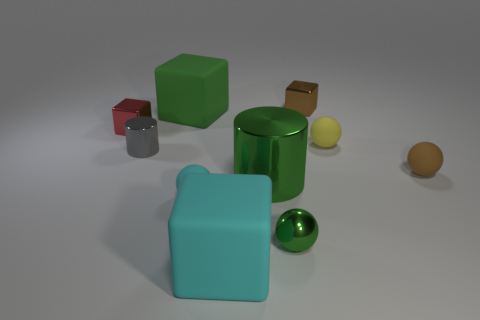Is there a tiny gray sphere that has the same material as the tiny green object? no 